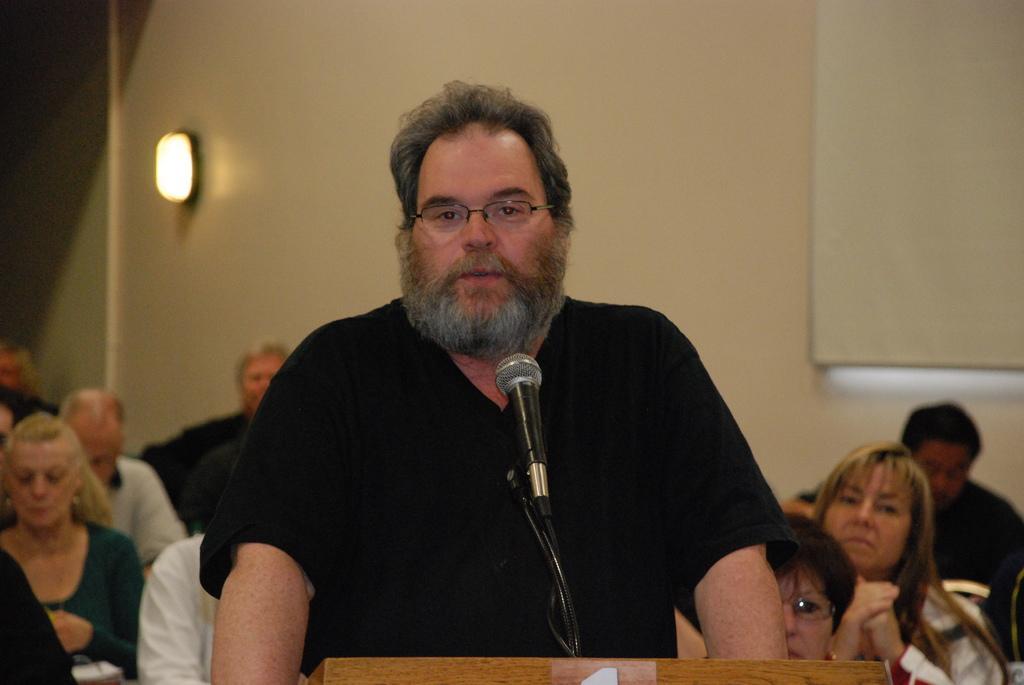In one or two sentences, can you explain what this image depicts? In the center of the image, we can see a person standing and wearing glasses and we can see a mic and a podium. In the background, there are some other people and we can see a board and a light on the wall. 